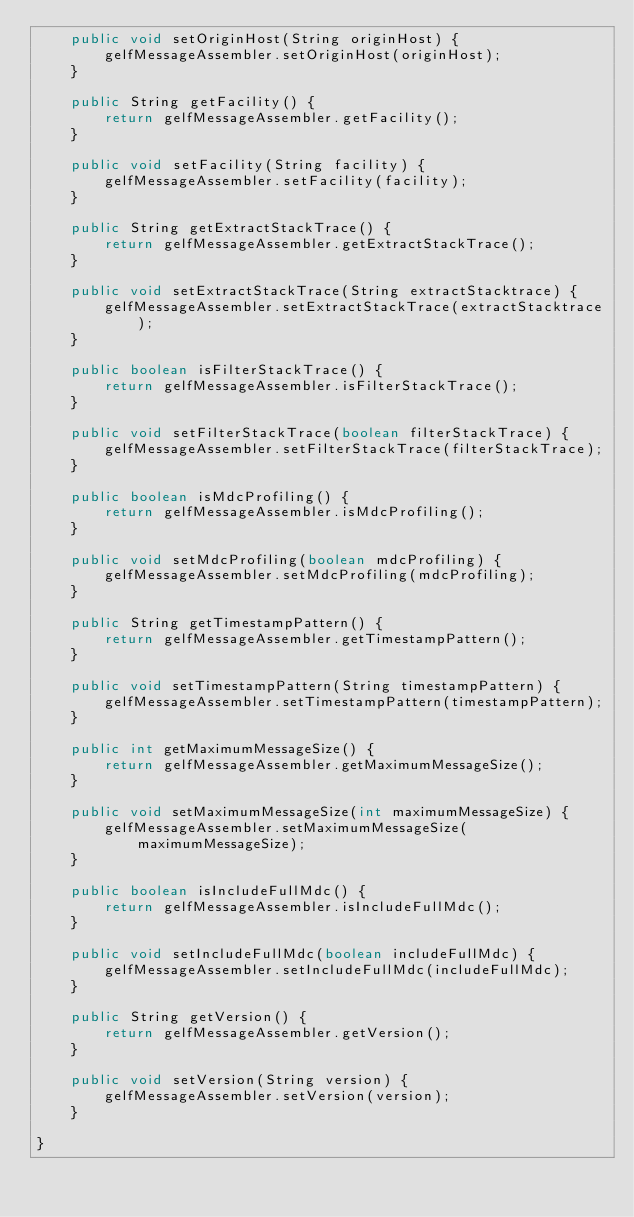<code> <loc_0><loc_0><loc_500><loc_500><_Java_>    public void setOriginHost(String originHost) {
        gelfMessageAssembler.setOriginHost(originHost);
    }

    public String getFacility() {
        return gelfMessageAssembler.getFacility();
    }

    public void setFacility(String facility) {
        gelfMessageAssembler.setFacility(facility);
    }

    public String getExtractStackTrace() {
        return gelfMessageAssembler.getExtractStackTrace();
    }

    public void setExtractStackTrace(String extractStacktrace) {
        gelfMessageAssembler.setExtractStackTrace(extractStacktrace);
    }

    public boolean isFilterStackTrace() {
        return gelfMessageAssembler.isFilterStackTrace();
    }

    public void setFilterStackTrace(boolean filterStackTrace) {
        gelfMessageAssembler.setFilterStackTrace(filterStackTrace);
    }

    public boolean isMdcProfiling() {
        return gelfMessageAssembler.isMdcProfiling();
    }

    public void setMdcProfiling(boolean mdcProfiling) {
        gelfMessageAssembler.setMdcProfiling(mdcProfiling);
    }

    public String getTimestampPattern() {
        return gelfMessageAssembler.getTimestampPattern();
    }

    public void setTimestampPattern(String timestampPattern) {
        gelfMessageAssembler.setTimestampPattern(timestampPattern);
    }

    public int getMaximumMessageSize() {
        return gelfMessageAssembler.getMaximumMessageSize();
    }

    public void setMaximumMessageSize(int maximumMessageSize) {
        gelfMessageAssembler.setMaximumMessageSize(maximumMessageSize);
    }

    public boolean isIncludeFullMdc() {
        return gelfMessageAssembler.isIncludeFullMdc();
    }

    public void setIncludeFullMdc(boolean includeFullMdc) {
        gelfMessageAssembler.setIncludeFullMdc(includeFullMdc);
    }

    public String getVersion() {
        return gelfMessageAssembler.getVersion();
    }

    public void setVersion(String version) {
        gelfMessageAssembler.setVersion(version);
    }

}
</code> 